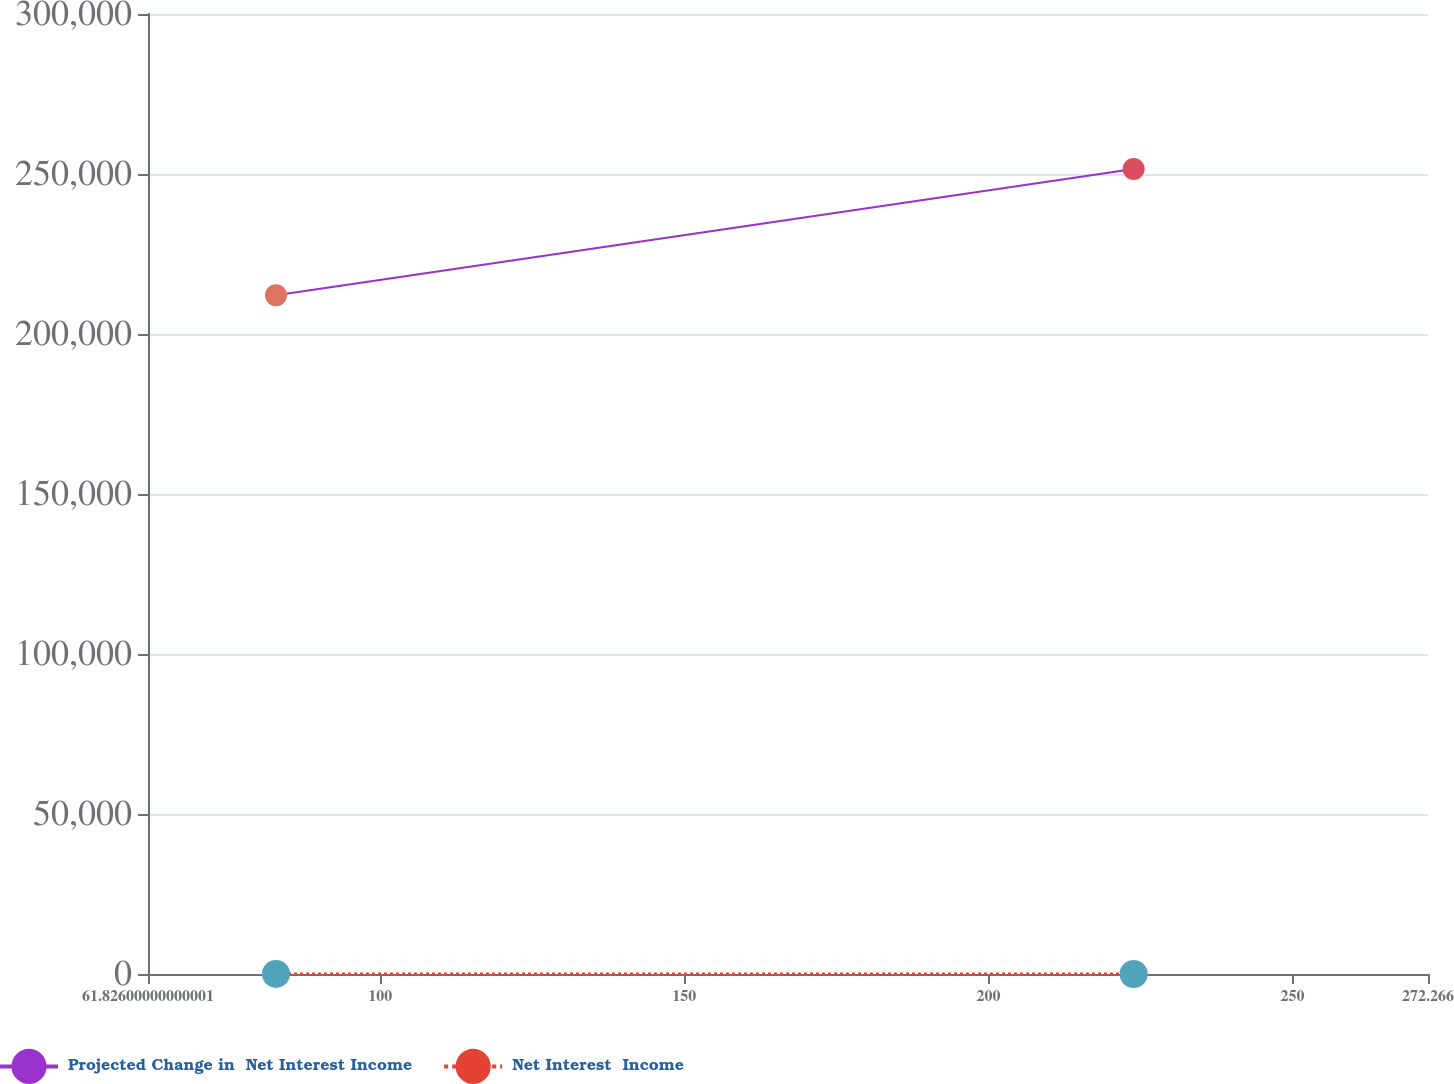Convert chart to OTSL. <chart><loc_0><loc_0><loc_500><loc_500><line_chart><ecel><fcel>Projected Change in  Net Interest Income<fcel>Net Interest  Income<nl><fcel>82.87<fcel>212115<fcel>8.68<nl><fcel>223.87<fcel>251572<fcel>6.62<nl><fcel>293.31<fcel>219561<fcel>4.13<nl></chart> 